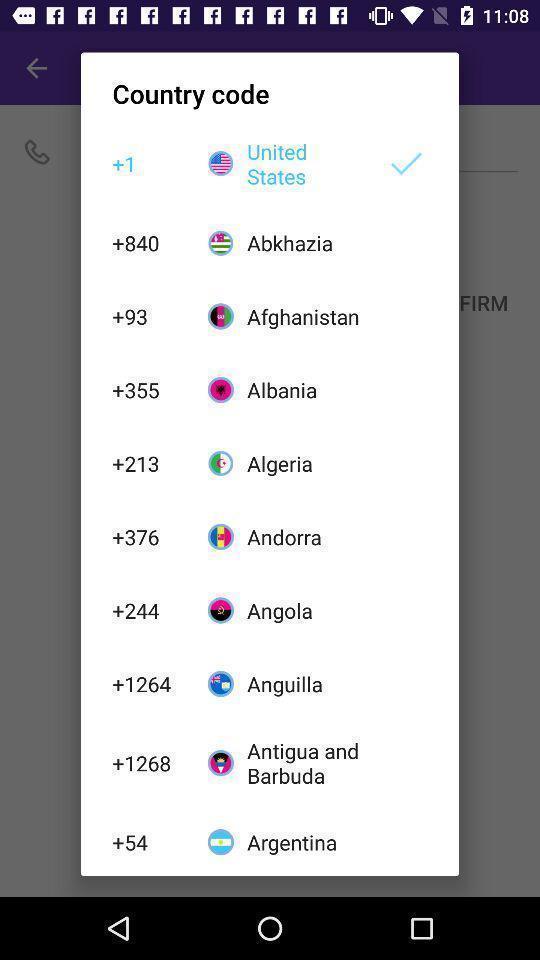Give me a narrative description of this picture. Popup to choose country code in the social app. 